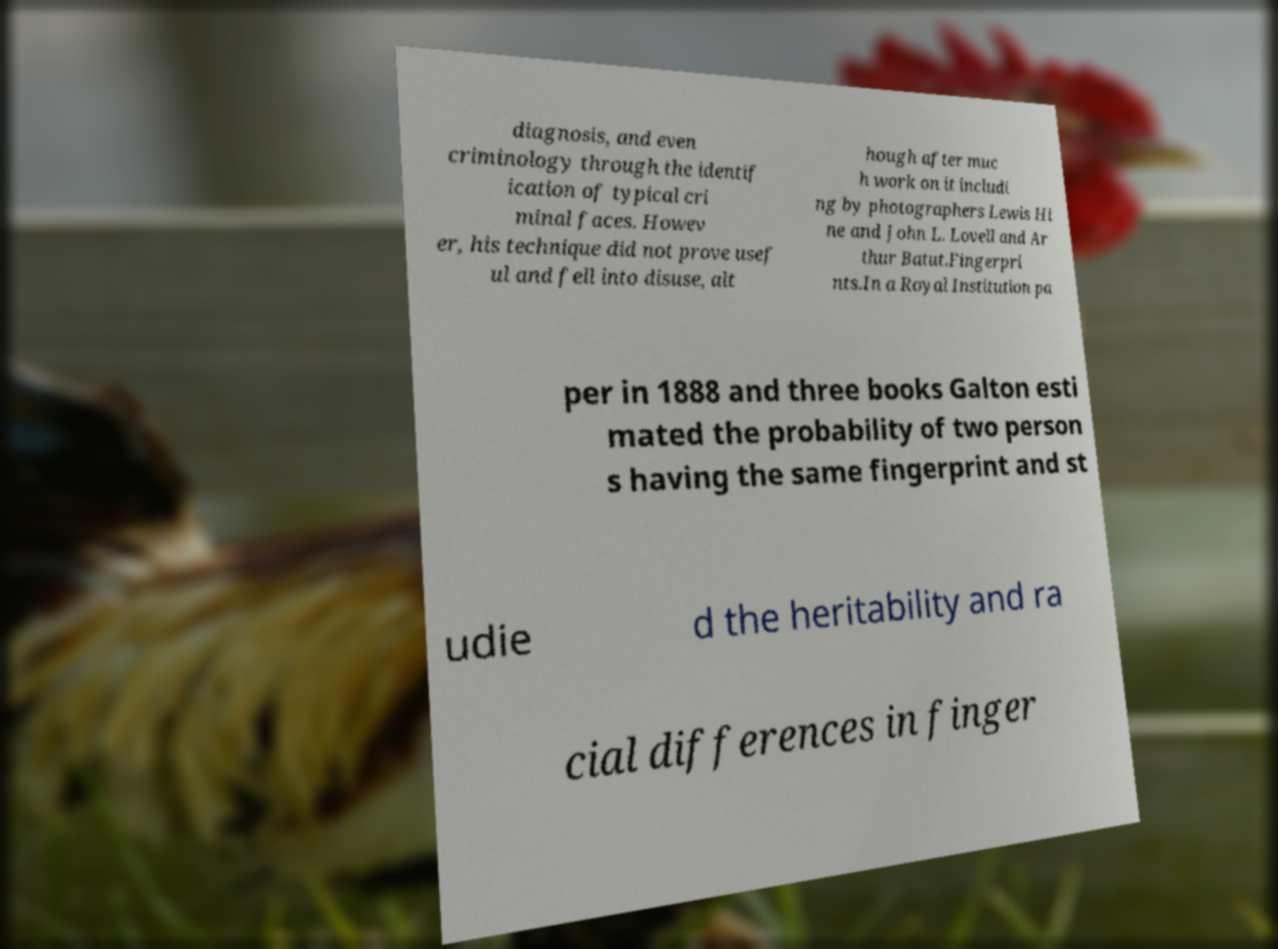Could you extract and type out the text from this image? diagnosis, and even criminology through the identif ication of typical cri minal faces. Howev er, his technique did not prove usef ul and fell into disuse, alt hough after muc h work on it includi ng by photographers Lewis Hi ne and John L. Lovell and Ar thur Batut.Fingerpri nts.In a Royal Institution pa per in 1888 and three books Galton esti mated the probability of two person s having the same fingerprint and st udie d the heritability and ra cial differences in finger 